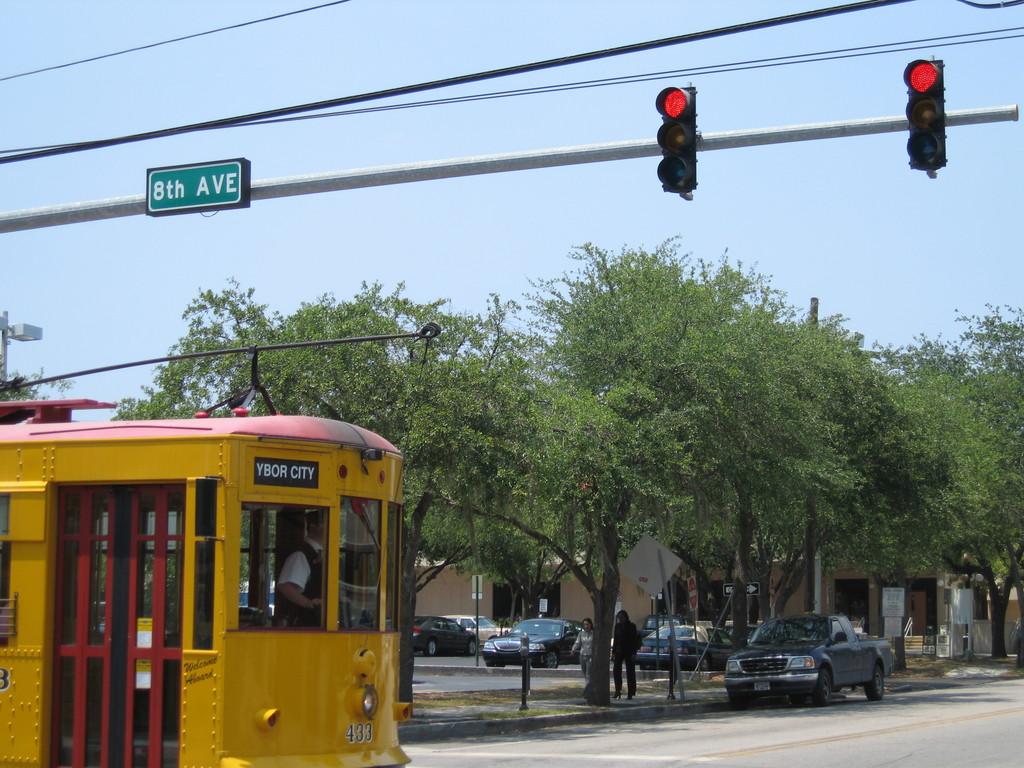Which street is shown on the sign?
Your answer should be very brief. 8th ave. What is written on the front of the streetcar?
Offer a very short reply. Ybor city. 